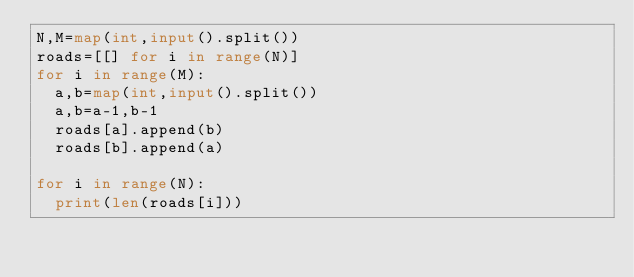Convert code to text. <code><loc_0><loc_0><loc_500><loc_500><_Python_>N,M=map(int,input().split())
roads=[[] for i in range(N)]
for i in range(M):
  a,b=map(int,input().split())
  a,b=a-1,b-1
  roads[a].append(b)
  roads[b].append(a)
  
for i in range(N):
  print(len(roads[i]))</code> 